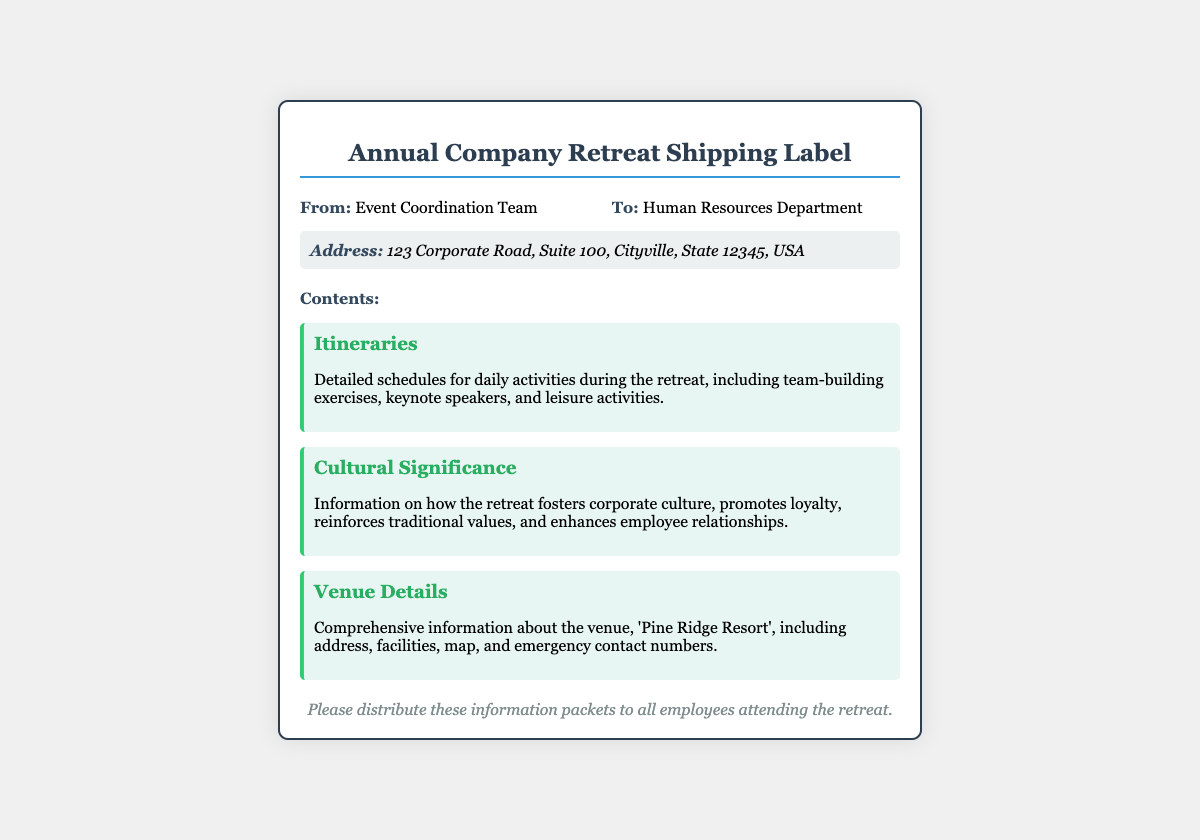What is the title of the document? The title of the document is indicated in the HTML <title> tag and also appears prominently at the top of the rendered label.
Answer: Annual Company Retreat Shipping Label Who is the sender? The sender's information appears in the "From:" section of the shipping label.
Answer: Event Coordination Team What is the recipient's department? The recipient's department is specified in the "To:" section of the label.
Answer: Human Resources Department What is the address listed on the label? The address is provided in the address section of the document, indicating where the packets should be sent.
Answer: 123 Corporate Road, Suite 100, Cityville, State 12345, USA What venues are mentioned in the contents? This information is found in the "Venue Details" section of the content-list.
Answer: Pine Ridge Resort What type of details are included in the itineraries? The itineraries detail the activities during the retreat as described in the content-list.
Answer: Detailed schedules for daily activities What is the cultural significance of the retreat? This details the retreat's impact on corporate culture as stated in the content-list.
Answer: Fosters corporate culture, promotes loyalty How should the information packets be distributed? The distribution instructions are mentioned in the notes section of the document.
Answer: Please distribute these information packets to all employees attending the retreat 